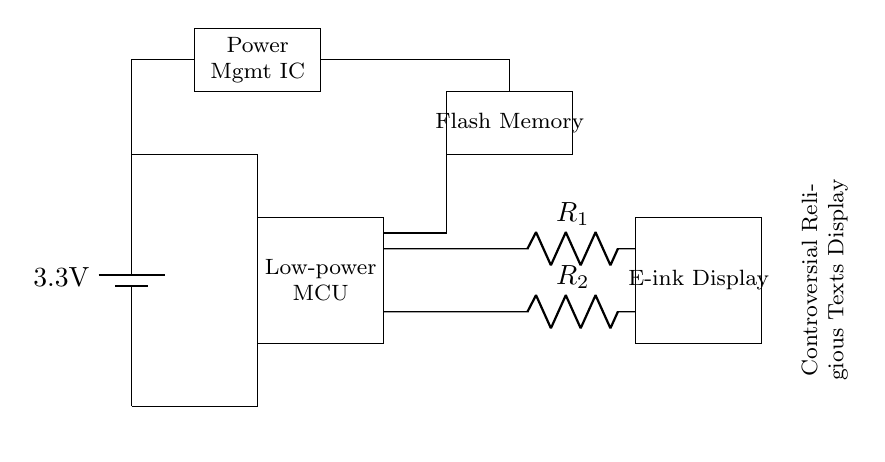What is the voltage supplied by the battery in the circuit? The battery is labeled as providing a voltage of 3.3 volts, which represents the potential difference it generates for the circuit components.
Answer: 3.3 volts What component is used as a power management IC? The circuit includes a rectangle labeled "Power Mgmt IC," indicating the presence of a power management integrated circuit that organizes power flow within the device.
Answer: Power Management IC How many resistors are present in the circuit, and what are their labels? There are two resistors in the circuit, labeled as "R1" and "R2," which are critical for limiting current and setting voltage levels across components.
Answer: Two; R1 and R2 What type of memory is incorporated into the circuit? The circuit features a storage component labeled "Flash Memory," which is a type of non-volatile memory often used in portable devices.
Answer: Flash Memory What does the circuit primarily display? The diagram includes a note indicating that it is designed to display "Controversial Religious Texts," suggesting that the purpose of the circuit is to showcase specific written content on the e-ink display.
Answer: Controversial Religious Texts What is the role of the low-power microcontroller in this circuit? The microcontroller, labeled as "Low-power MCU," controls the operation of the e-ink display, facilitating updates and interactions with the displayed content while managing energy consumption effectively.
Answer: Control How does the power supply connect to the microcontroller and the rest of the circuit? The power supply connects to the microcontroller through a direct line and routes power to other components like the flash memory and e-ink display, ensuring that each part has access to the necessary voltage.
Answer: Direct line connections 